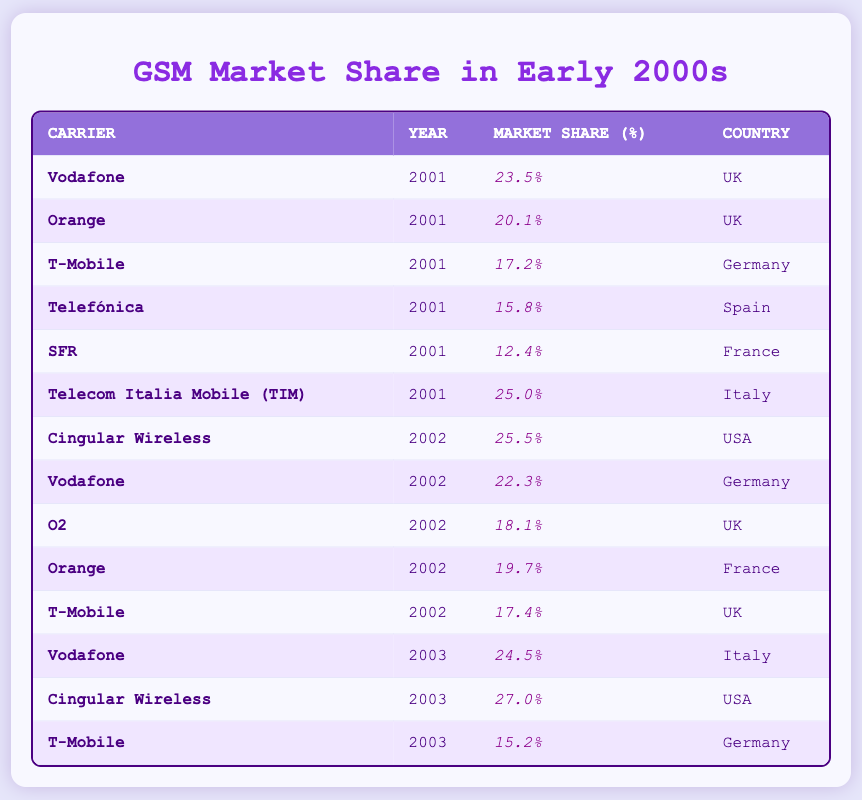What was the market share of Vodafone in 2001? The table shows that Vodafone's market share in 2001 was listed directly, showing it as 23.5% in the UK.
Answer: 23.5% Which carrier had the highest market share in Italy during the early 2000s? Looking at the data for Italy, Vodafone had the highest market share of 24.5% in 2003, which stands out compared to other carriers in the same country.
Answer: Vodafone What is the average market share of Orange in 2001 and 2002? Orange had a market share of 20.1% in 2001 and 19.7% in 2002. To find the average: (20.1 + 19.7) / 2 = 19.9.
Answer: 19.9% Did T-Mobile's market share increase from 2002 to 2003 in Germany? T-Mobile's market share in Germany was 17.4% in 2002 and decreased to 15.2% in 2003, indicating a decrease. Thus, the statement is false.
Answer: No Which carrier had a market share of over 25% in the USA during the early 2000s, and in what year? The table indicates that Cingular Wireless had a market share of 25.5% in 2002 and then increased to 27.0% in 2003, validating that it crossed the 25% mark.
Answer: Cingular Wireless in 2002 and 2003 How much higher was the market share of Cingular Wireless in 2003 compared to T-Mobile's in 2003? Cingular Wireless had a market share of 27.0% in 2003 while T-Mobile had 15.2%. The difference is 27.0% - 15.2% = 11.8%.
Answer: 11.8% In which country did Telefónica have its market share listed, and what was the percentage? The data shows that Telefónica operated in Spain with a market share of 15.8% in 2001, which can be referenced directly from the table entry.
Answer: Spain, 15.8% Was SFR's market share in 2001 greater than 10%? Since SFR's market share is listed as 12.4% in 2001, it is indeed greater than 10%, confirming the statement as true.
Answer: Yes What trend can be observed for Vodafone's market share from 2001 to 2003 in Italy? Vodafone's market share rose from 23.5% in 2001 to 24.5% in 2003, observing an increasing trend over the years.
Answer: Increasing Which country had the highest single carrier market share, and which carrier was it? The table shows Telecom Italia Mobile (TIM) with 25.0% in Italy in 2001. This is the highest single market share noted for any carrier across the provided data.
Answer: Telecom Italia Mobile in Italy How does the market share of T-Mobile in Germany in 2001 compare with that in 2003? T-Mobile had a market share of 17.2% in 2001 and decreased to 15.2% in 2003, suggesting a decline in its market share over these years.
Answer: Decreased 